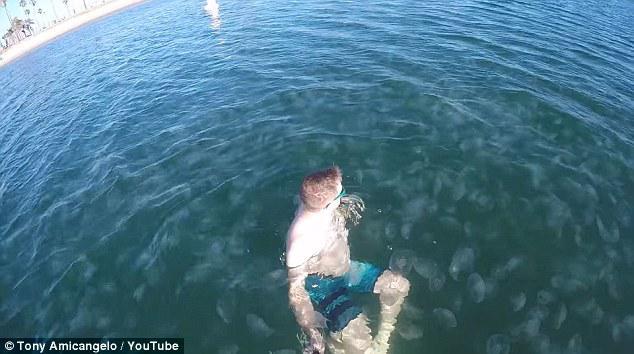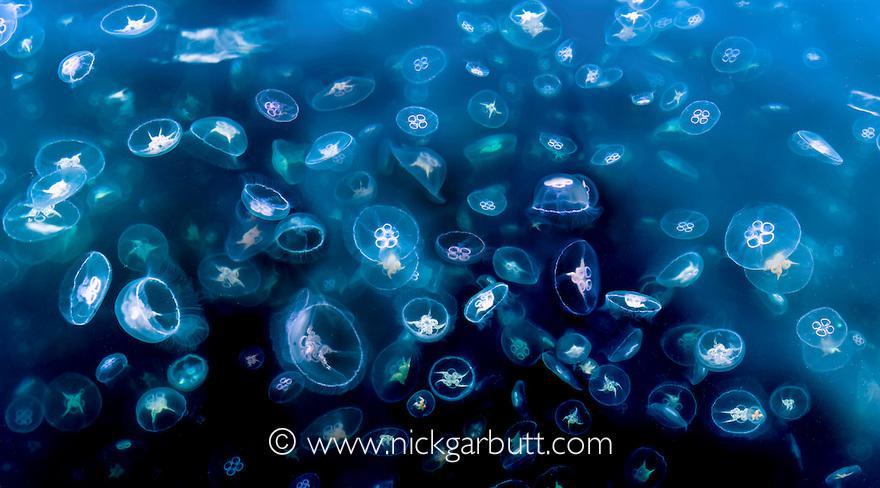The first image is the image on the left, the second image is the image on the right. Examine the images to the left and right. Is the description "The surface of the water is visible." accurate? Answer yes or no. Yes. The first image is the image on the left, the second image is the image on the right. Analyze the images presented: Is the assertion "One of the images has a person in the lwater with the sting rays." valid? Answer yes or no. Yes. 